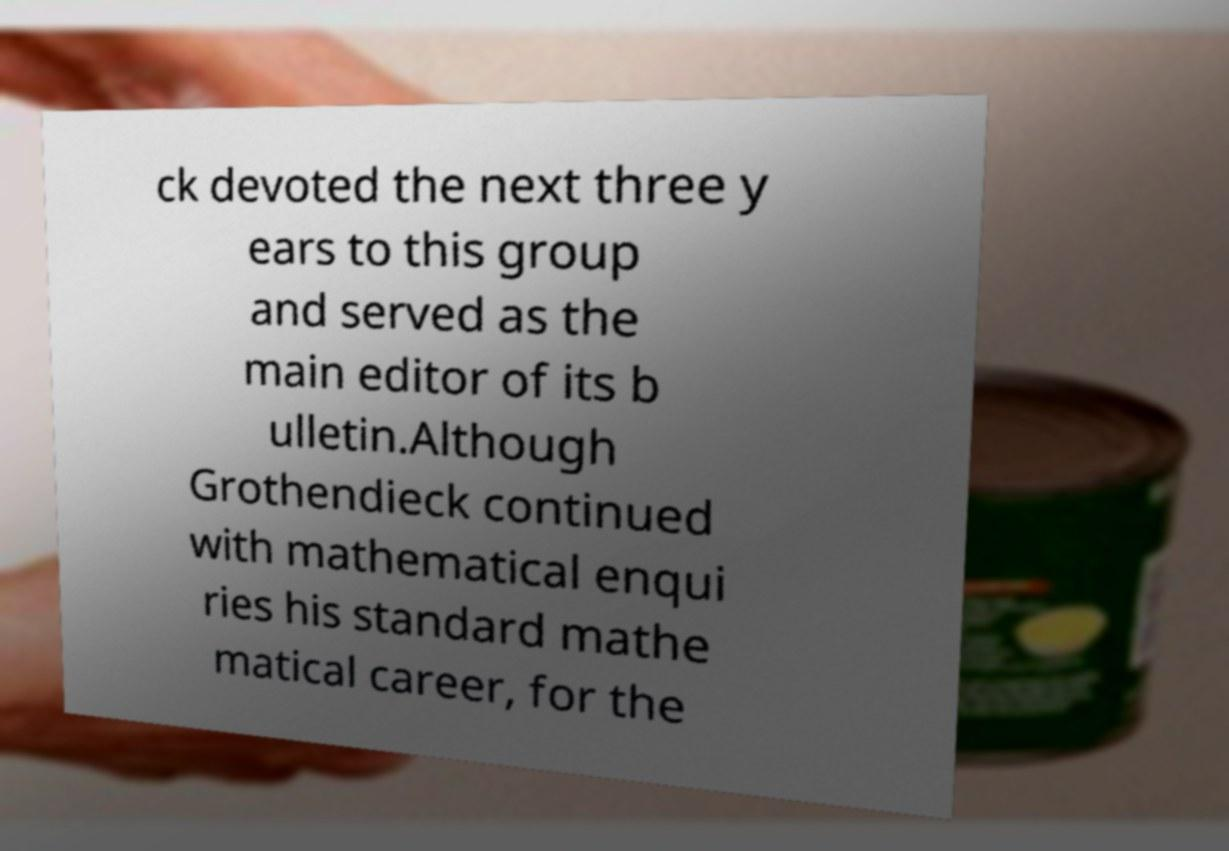I need the written content from this picture converted into text. Can you do that? ck devoted the next three y ears to this group and served as the main editor of its b ulletin.Although Grothendieck continued with mathematical enqui ries his standard mathe matical career, for the 